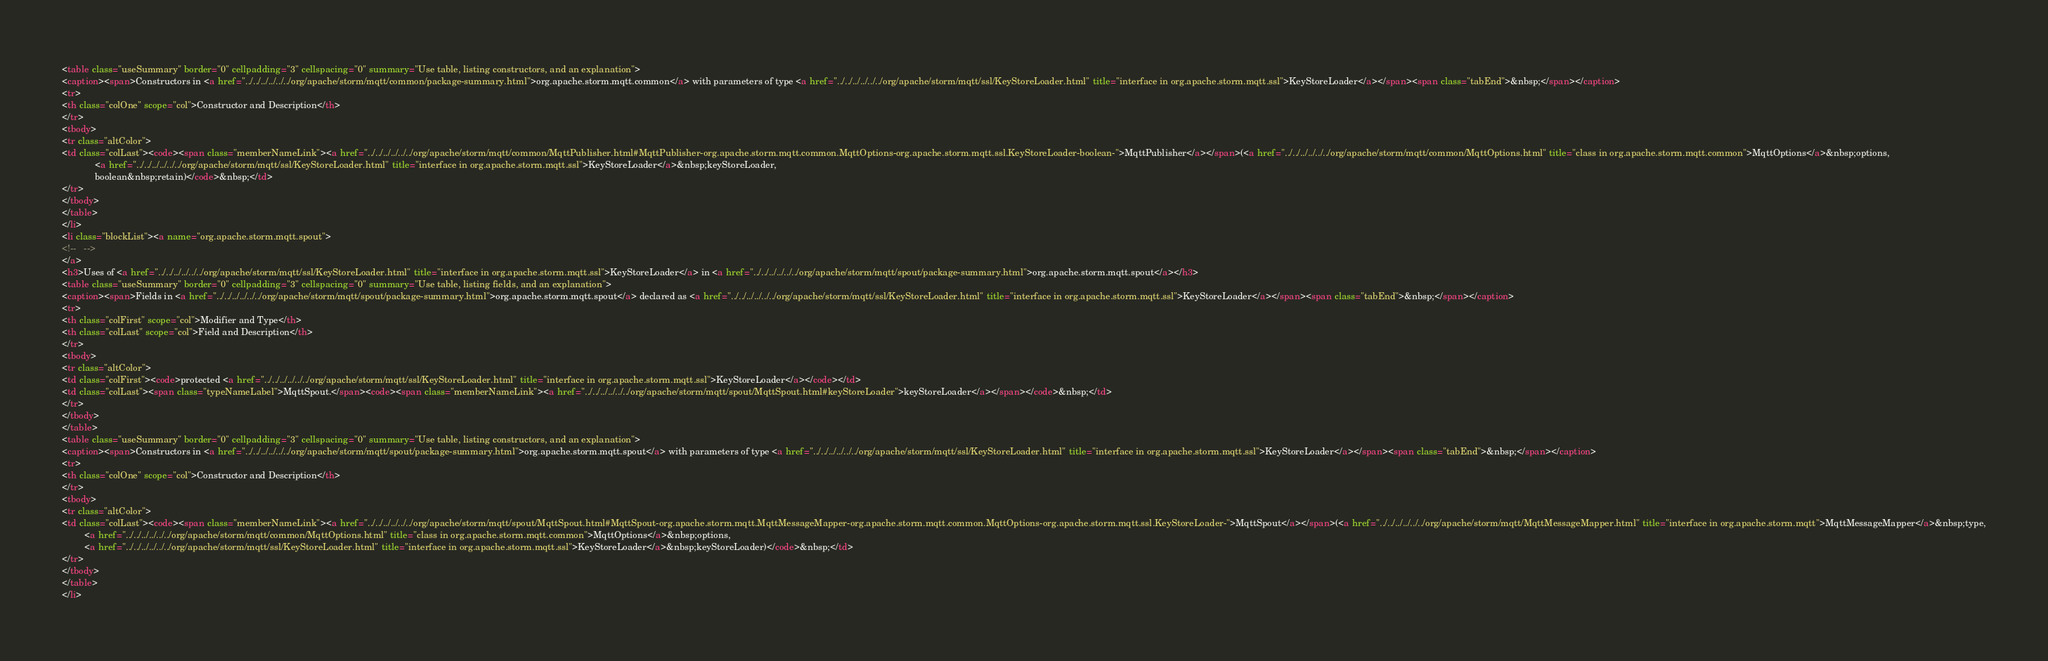<code> <loc_0><loc_0><loc_500><loc_500><_HTML_><table class="useSummary" border="0" cellpadding="3" cellspacing="0" summary="Use table, listing constructors, and an explanation">
<caption><span>Constructors in <a href="../../../../../../org/apache/storm/mqtt/common/package-summary.html">org.apache.storm.mqtt.common</a> with parameters of type <a href="../../../../../../org/apache/storm/mqtt/ssl/KeyStoreLoader.html" title="interface in org.apache.storm.mqtt.ssl">KeyStoreLoader</a></span><span class="tabEnd">&nbsp;</span></caption>
<tr>
<th class="colOne" scope="col">Constructor and Description</th>
</tr>
<tbody>
<tr class="altColor">
<td class="colLast"><code><span class="memberNameLink"><a href="../../../../../../org/apache/storm/mqtt/common/MqttPublisher.html#MqttPublisher-org.apache.storm.mqtt.common.MqttOptions-org.apache.storm.mqtt.ssl.KeyStoreLoader-boolean-">MqttPublisher</a></span>(<a href="../../../../../../org/apache/storm/mqtt/common/MqttOptions.html" title="class in org.apache.storm.mqtt.common">MqttOptions</a>&nbsp;options,
             <a href="../../../../../../org/apache/storm/mqtt/ssl/KeyStoreLoader.html" title="interface in org.apache.storm.mqtt.ssl">KeyStoreLoader</a>&nbsp;keyStoreLoader,
             boolean&nbsp;retain)</code>&nbsp;</td>
</tr>
</tbody>
</table>
</li>
<li class="blockList"><a name="org.apache.storm.mqtt.spout">
<!--   -->
</a>
<h3>Uses of <a href="../../../../../../org/apache/storm/mqtt/ssl/KeyStoreLoader.html" title="interface in org.apache.storm.mqtt.ssl">KeyStoreLoader</a> in <a href="../../../../../../org/apache/storm/mqtt/spout/package-summary.html">org.apache.storm.mqtt.spout</a></h3>
<table class="useSummary" border="0" cellpadding="3" cellspacing="0" summary="Use table, listing fields, and an explanation">
<caption><span>Fields in <a href="../../../../../../org/apache/storm/mqtt/spout/package-summary.html">org.apache.storm.mqtt.spout</a> declared as <a href="../../../../../../org/apache/storm/mqtt/ssl/KeyStoreLoader.html" title="interface in org.apache.storm.mqtt.ssl">KeyStoreLoader</a></span><span class="tabEnd">&nbsp;</span></caption>
<tr>
<th class="colFirst" scope="col">Modifier and Type</th>
<th class="colLast" scope="col">Field and Description</th>
</tr>
<tbody>
<tr class="altColor">
<td class="colFirst"><code>protected <a href="../../../../../../org/apache/storm/mqtt/ssl/KeyStoreLoader.html" title="interface in org.apache.storm.mqtt.ssl">KeyStoreLoader</a></code></td>
<td class="colLast"><span class="typeNameLabel">MqttSpout.</span><code><span class="memberNameLink"><a href="../../../../../../org/apache/storm/mqtt/spout/MqttSpout.html#keyStoreLoader">keyStoreLoader</a></span></code>&nbsp;</td>
</tr>
</tbody>
</table>
<table class="useSummary" border="0" cellpadding="3" cellspacing="0" summary="Use table, listing constructors, and an explanation">
<caption><span>Constructors in <a href="../../../../../../org/apache/storm/mqtt/spout/package-summary.html">org.apache.storm.mqtt.spout</a> with parameters of type <a href="../../../../../../org/apache/storm/mqtt/ssl/KeyStoreLoader.html" title="interface in org.apache.storm.mqtt.ssl">KeyStoreLoader</a></span><span class="tabEnd">&nbsp;</span></caption>
<tr>
<th class="colOne" scope="col">Constructor and Description</th>
</tr>
<tbody>
<tr class="altColor">
<td class="colLast"><code><span class="memberNameLink"><a href="../../../../../../org/apache/storm/mqtt/spout/MqttSpout.html#MqttSpout-org.apache.storm.mqtt.MqttMessageMapper-org.apache.storm.mqtt.common.MqttOptions-org.apache.storm.mqtt.ssl.KeyStoreLoader-">MqttSpout</a></span>(<a href="../../../../../../org/apache/storm/mqtt/MqttMessageMapper.html" title="interface in org.apache.storm.mqtt">MqttMessageMapper</a>&nbsp;type,
         <a href="../../../../../../org/apache/storm/mqtt/common/MqttOptions.html" title="class in org.apache.storm.mqtt.common">MqttOptions</a>&nbsp;options,
         <a href="../../../../../../org/apache/storm/mqtt/ssl/KeyStoreLoader.html" title="interface in org.apache.storm.mqtt.ssl">KeyStoreLoader</a>&nbsp;keyStoreLoader)</code>&nbsp;</td>
</tr>
</tbody>
</table>
</li></code> 